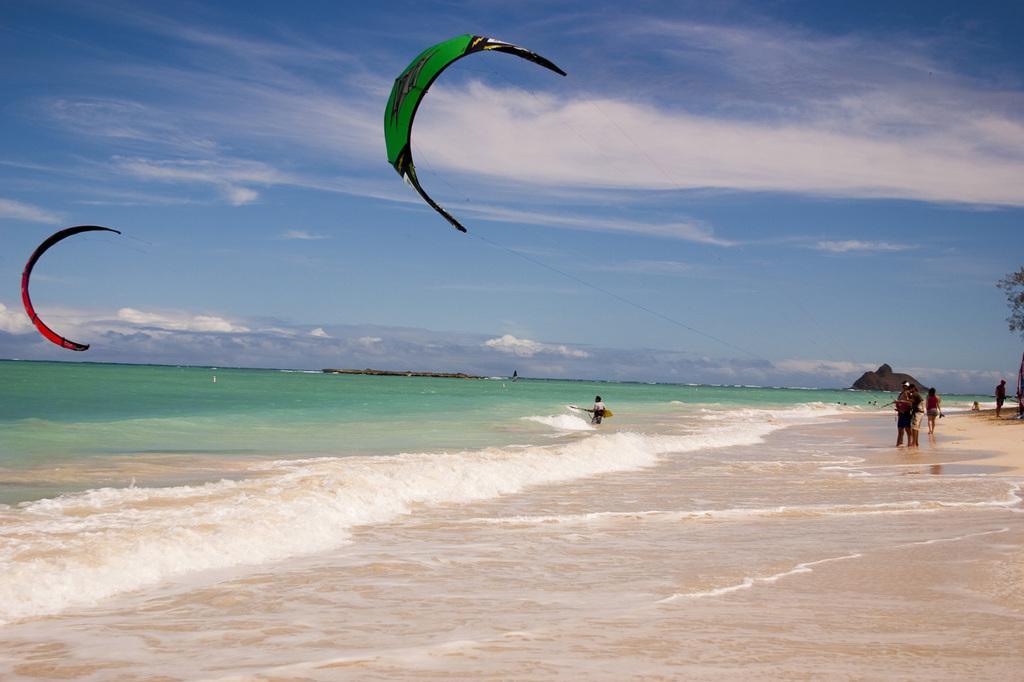Can you describe this image briefly? In this image there are people, hill's, leaves, water, cloudy sky and paragliding. Paragliding are in the air.  